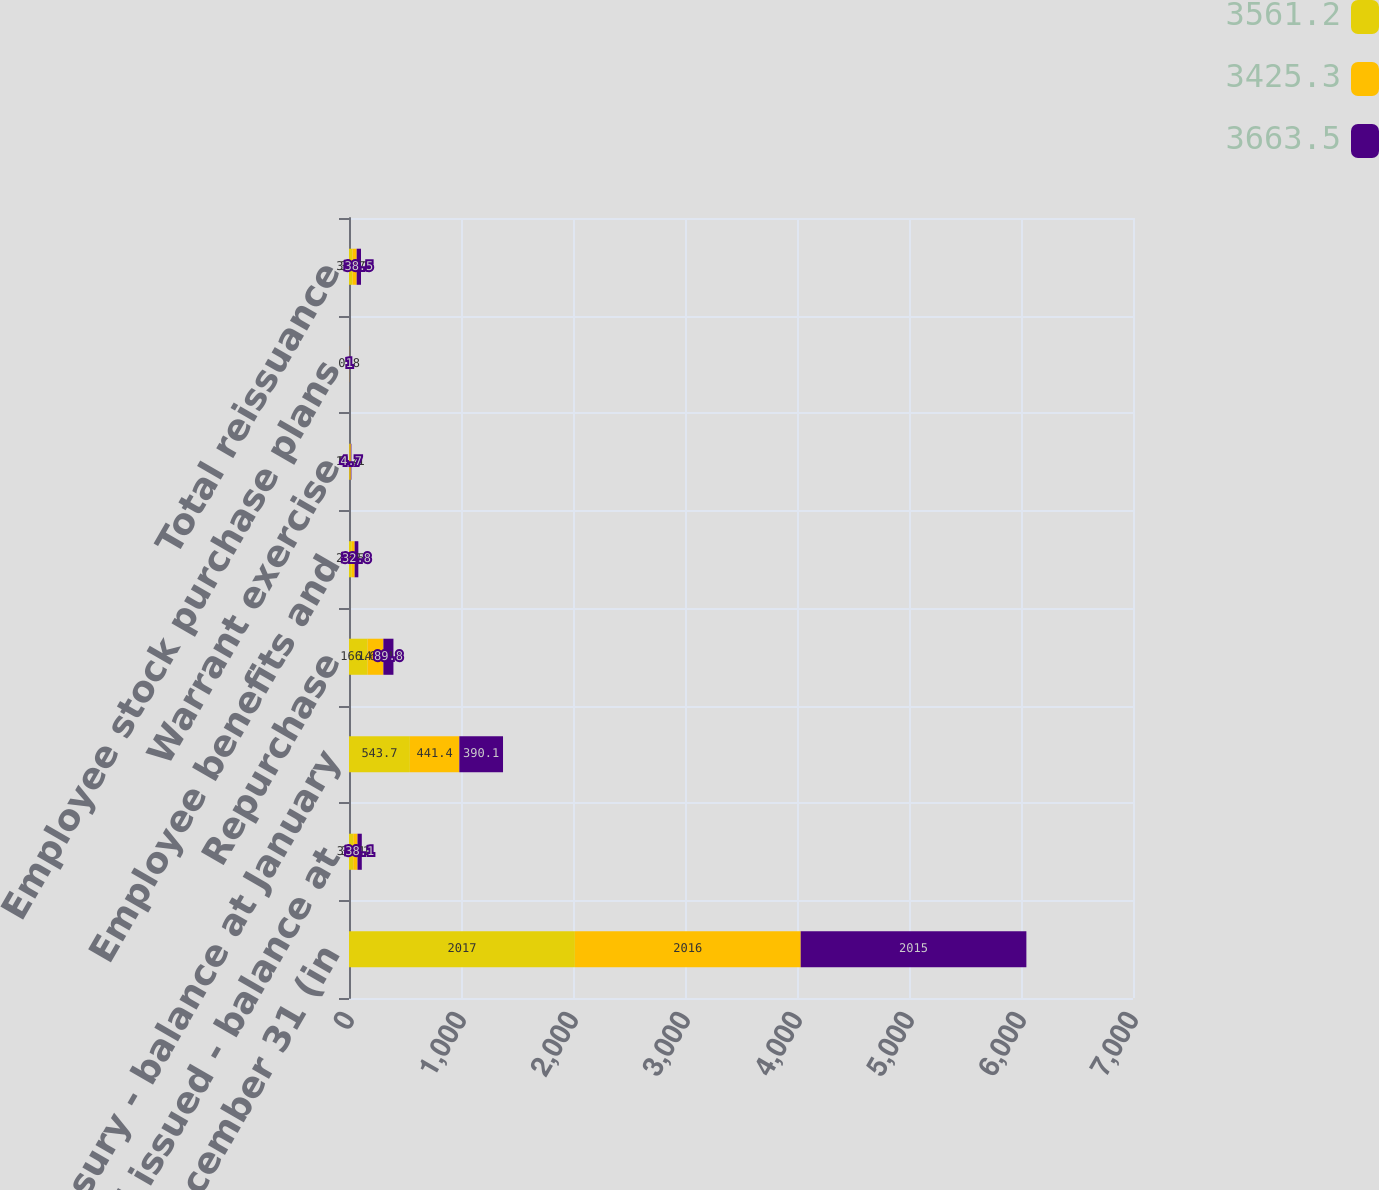<chart> <loc_0><loc_0><loc_500><loc_500><stacked_bar_chart><ecel><fcel>Year ended December 31 (in<fcel>Total issued - balance at<fcel>Treasury - balance at January<fcel>Repurchase<fcel>Employee benefits and<fcel>Warrant exercise<fcel>Employee stock purchase plans<fcel>Total reissuance<nl><fcel>3561.2<fcel>2017<fcel>38.1<fcel>543.7<fcel>166.6<fcel>24.5<fcel>5.4<fcel>0.8<fcel>30.7<nl><fcel>3425.3<fcel>2016<fcel>38.1<fcel>441.4<fcel>140.4<fcel>26<fcel>11.1<fcel>1<fcel>38.1<nl><fcel>3663.5<fcel>2015<fcel>38.1<fcel>390.1<fcel>89.8<fcel>32.8<fcel>4.7<fcel>1<fcel>38.5<nl></chart> 